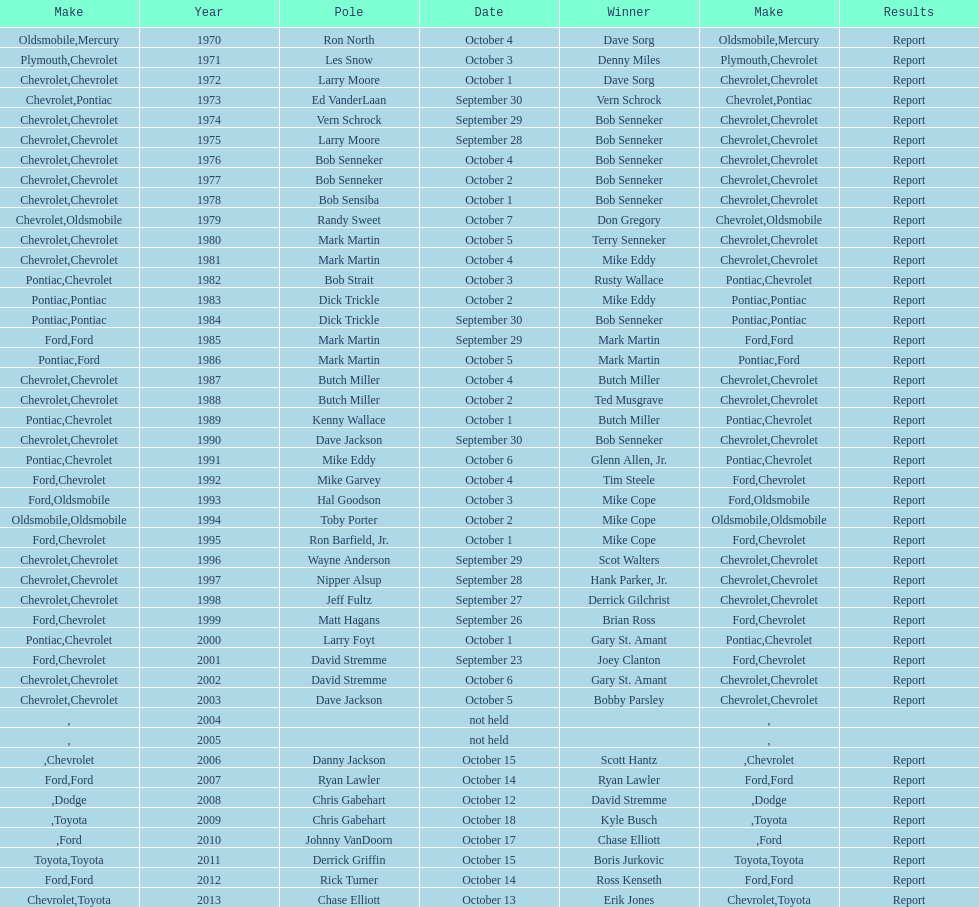Which month held the most winchester 400 races? October. 